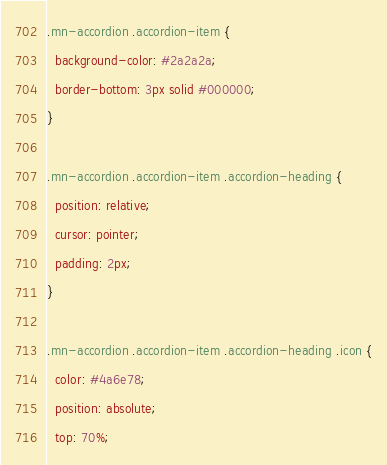Convert code to text. <code><loc_0><loc_0><loc_500><loc_500><_CSS_>.mn-accordion .accordion-item {
  background-color: #2a2a2a;
  border-bottom: 3px solid #000000;
}

.mn-accordion .accordion-item .accordion-heading {
  position: relative;
  cursor: pointer;
  padding: 2px;
}

.mn-accordion .accordion-item .accordion-heading .icon {
  color: #4a6e78;
  position: absolute;
  top: 70%;</code> 